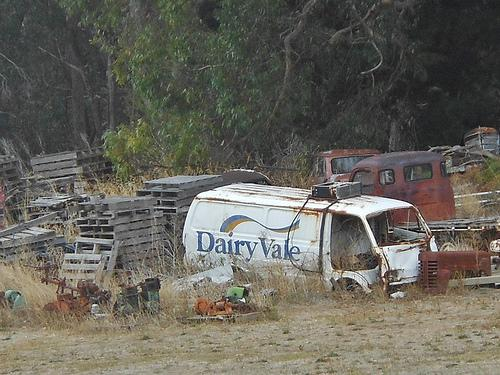Question: what color is the tree?
Choices:
A. Brown.
B. Green.
C. Black.
D. Gray.
Answer with the letter. Answer: B Question: how many vans are there?
Choices:
A. Two.
B. Three.
C. Four.
D. One.
Answer with the letter. Answer: D 